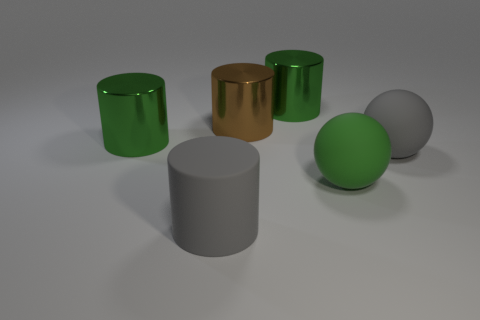Add 1 large green metallic cylinders. How many objects exist? 7 Subtract all gray matte cylinders. How many cylinders are left? 3 Subtract 4 cylinders. How many cylinders are left? 0 Subtract all balls. How many objects are left? 4 Subtract all purple balls. How many blue cylinders are left? 0 Subtract all big yellow matte cylinders. Subtract all rubber spheres. How many objects are left? 4 Add 5 big green metal objects. How many big green metal objects are left? 7 Add 4 matte objects. How many matte objects exist? 7 Subtract all green cylinders. How many cylinders are left? 2 Subtract 2 green cylinders. How many objects are left? 4 